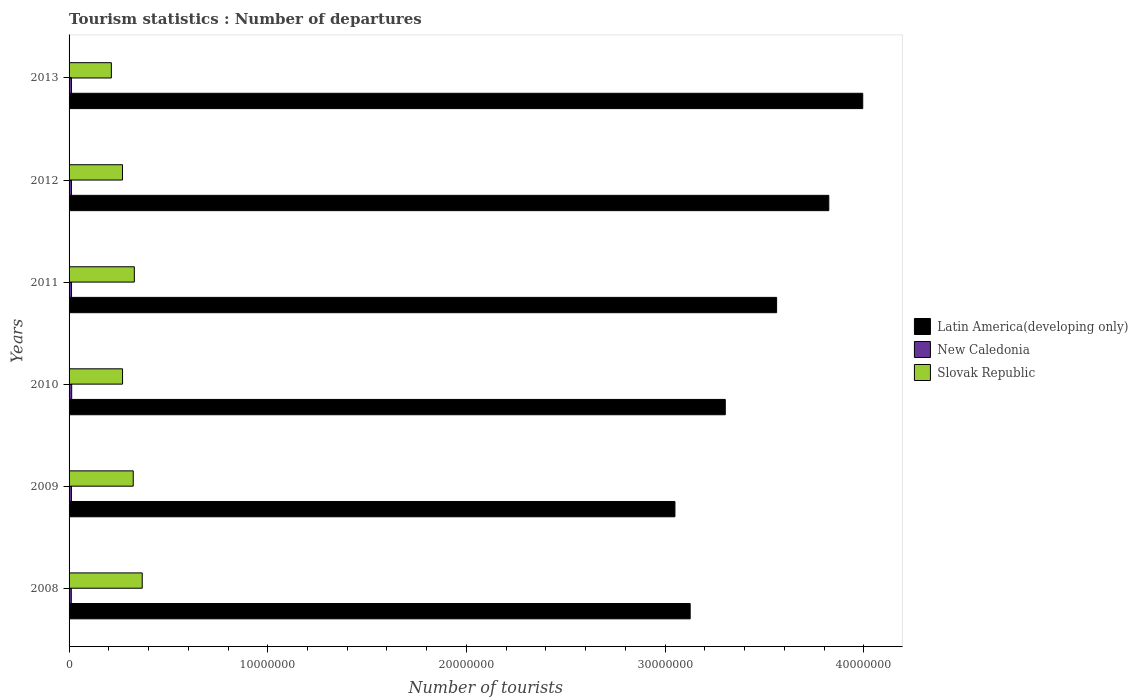How many different coloured bars are there?
Provide a succinct answer. 3. How many groups of bars are there?
Your response must be concise. 6. Are the number of bars per tick equal to the number of legend labels?
Your response must be concise. Yes. Are the number of bars on each tick of the Y-axis equal?
Your answer should be compact. Yes. How many bars are there on the 6th tick from the top?
Give a very brief answer. 3. What is the label of the 1st group of bars from the top?
Your answer should be very brief. 2013. What is the number of tourist departures in New Caledonia in 2012?
Provide a succinct answer. 1.21e+05. Across all years, what is the maximum number of tourist departures in Slovak Republic?
Your response must be concise. 3.68e+06. Across all years, what is the minimum number of tourist departures in New Caledonia?
Keep it short and to the point. 1.12e+05. What is the total number of tourist departures in Slovak Republic in the graph?
Offer a terse response. 1.77e+07. What is the difference between the number of tourist departures in Slovak Republic in 2009 and that in 2012?
Ensure brevity in your answer.  5.41e+05. What is the difference between the number of tourist departures in Slovak Republic in 2010 and the number of tourist departures in New Caledonia in 2009?
Keep it short and to the point. 2.57e+06. What is the average number of tourist departures in Slovak Republic per year?
Provide a succinct answer. 2.95e+06. In the year 2008, what is the difference between the number of tourist departures in Latin America(developing only) and number of tourist departures in Slovak Republic?
Provide a succinct answer. 2.76e+07. What is the ratio of the number of tourist departures in Latin America(developing only) in 2009 to that in 2012?
Provide a succinct answer. 0.8. What is the difference between the highest and the second highest number of tourist departures in New Caledonia?
Make the answer very short. 8000. What is the difference between the highest and the lowest number of tourist departures in Latin America(developing only)?
Ensure brevity in your answer.  9.45e+06. What does the 2nd bar from the top in 2008 represents?
Your answer should be very brief. New Caledonia. What does the 2nd bar from the bottom in 2010 represents?
Offer a very short reply. New Caledonia. How many bars are there?
Your answer should be compact. 18. Are all the bars in the graph horizontal?
Offer a terse response. Yes. What is the difference between two consecutive major ticks on the X-axis?
Give a very brief answer. 1.00e+07. Are the values on the major ticks of X-axis written in scientific E-notation?
Give a very brief answer. No. Does the graph contain any zero values?
Make the answer very short. No. Does the graph contain grids?
Your response must be concise. No. How many legend labels are there?
Keep it short and to the point. 3. What is the title of the graph?
Your response must be concise. Tourism statistics : Number of departures. What is the label or title of the X-axis?
Ensure brevity in your answer.  Number of tourists. What is the Number of tourists in Latin America(developing only) in 2008?
Make the answer very short. 3.13e+07. What is the Number of tourists of New Caledonia in 2008?
Give a very brief answer. 1.12e+05. What is the Number of tourists in Slovak Republic in 2008?
Your answer should be very brief. 3.68e+06. What is the Number of tourists in Latin America(developing only) in 2009?
Keep it short and to the point. 3.05e+07. What is the Number of tourists in New Caledonia in 2009?
Offer a very short reply. 1.19e+05. What is the Number of tourists in Slovak Republic in 2009?
Provide a succinct answer. 3.23e+06. What is the Number of tourists in Latin America(developing only) in 2010?
Ensure brevity in your answer.  3.30e+07. What is the Number of tourists of New Caledonia in 2010?
Your answer should be compact. 1.32e+05. What is the Number of tourists of Slovak Republic in 2010?
Provide a succinct answer. 2.69e+06. What is the Number of tourists of Latin America(developing only) in 2011?
Your answer should be very brief. 3.56e+07. What is the Number of tourists of New Caledonia in 2011?
Offer a very short reply. 1.24e+05. What is the Number of tourists of Slovak Republic in 2011?
Make the answer very short. 3.28e+06. What is the Number of tourists of Latin America(developing only) in 2012?
Give a very brief answer. 3.82e+07. What is the Number of tourists in New Caledonia in 2012?
Give a very brief answer. 1.21e+05. What is the Number of tourists in Slovak Republic in 2012?
Give a very brief answer. 2.69e+06. What is the Number of tourists of Latin America(developing only) in 2013?
Ensure brevity in your answer.  3.99e+07. What is the Number of tourists of New Caledonia in 2013?
Provide a succinct answer. 1.21e+05. What is the Number of tourists of Slovak Republic in 2013?
Your response must be concise. 2.13e+06. Across all years, what is the maximum Number of tourists of Latin America(developing only)?
Provide a succinct answer. 3.99e+07. Across all years, what is the maximum Number of tourists of New Caledonia?
Offer a very short reply. 1.32e+05. Across all years, what is the maximum Number of tourists in Slovak Republic?
Provide a short and direct response. 3.68e+06. Across all years, what is the minimum Number of tourists in Latin America(developing only)?
Offer a terse response. 3.05e+07. Across all years, what is the minimum Number of tourists in New Caledonia?
Ensure brevity in your answer.  1.12e+05. Across all years, what is the minimum Number of tourists in Slovak Republic?
Offer a very short reply. 2.13e+06. What is the total Number of tourists of Latin America(developing only) in the graph?
Your answer should be very brief. 2.09e+08. What is the total Number of tourists in New Caledonia in the graph?
Provide a short and direct response. 7.29e+05. What is the total Number of tourists in Slovak Republic in the graph?
Ensure brevity in your answer.  1.77e+07. What is the difference between the Number of tourists of Latin America(developing only) in 2008 and that in 2009?
Offer a terse response. 7.67e+05. What is the difference between the Number of tourists of New Caledonia in 2008 and that in 2009?
Ensure brevity in your answer.  -7000. What is the difference between the Number of tourists of Slovak Republic in 2008 and that in 2009?
Offer a terse response. 4.53e+05. What is the difference between the Number of tourists in Latin America(developing only) in 2008 and that in 2010?
Ensure brevity in your answer.  -1.77e+06. What is the difference between the Number of tourists of Slovak Republic in 2008 and that in 2010?
Offer a very short reply. 9.91e+05. What is the difference between the Number of tourists of Latin America(developing only) in 2008 and that in 2011?
Ensure brevity in your answer.  -4.35e+06. What is the difference between the Number of tourists of New Caledonia in 2008 and that in 2011?
Provide a short and direct response. -1.20e+04. What is the difference between the Number of tourists of Slovak Republic in 2008 and that in 2011?
Your answer should be very brief. 3.98e+05. What is the difference between the Number of tourists in Latin America(developing only) in 2008 and that in 2012?
Your answer should be very brief. -6.98e+06. What is the difference between the Number of tourists of New Caledonia in 2008 and that in 2012?
Provide a short and direct response. -9000. What is the difference between the Number of tourists in Slovak Republic in 2008 and that in 2012?
Your response must be concise. 9.94e+05. What is the difference between the Number of tourists in Latin America(developing only) in 2008 and that in 2013?
Give a very brief answer. -8.69e+06. What is the difference between the Number of tourists of New Caledonia in 2008 and that in 2013?
Ensure brevity in your answer.  -9000. What is the difference between the Number of tourists of Slovak Republic in 2008 and that in 2013?
Keep it short and to the point. 1.55e+06. What is the difference between the Number of tourists in Latin America(developing only) in 2009 and that in 2010?
Offer a very short reply. -2.53e+06. What is the difference between the Number of tourists of New Caledonia in 2009 and that in 2010?
Your answer should be very brief. -1.30e+04. What is the difference between the Number of tourists of Slovak Republic in 2009 and that in 2010?
Offer a terse response. 5.38e+05. What is the difference between the Number of tourists of Latin America(developing only) in 2009 and that in 2011?
Your answer should be compact. -5.12e+06. What is the difference between the Number of tourists in New Caledonia in 2009 and that in 2011?
Your response must be concise. -5000. What is the difference between the Number of tourists in Slovak Republic in 2009 and that in 2011?
Your answer should be compact. -5.50e+04. What is the difference between the Number of tourists of Latin America(developing only) in 2009 and that in 2012?
Your answer should be very brief. -7.74e+06. What is the difference between the Number of tourists of New Caledonia in 2009 and that in 2012?
Offer a terse response. -2000. What is the difference between the Number of tourists in Slovak Republic in 2009 and that in 2012?
Your answer should be very brief. 5.41e+05. What is the difference between the Number of tourists of Latin America(developing only) in 2009 and that in 2013?
Make the answer very short. -9.45e+06. What is the difference between the Number of tourists in New Caledonia in 2009 and that in 2013?
Your answer should be compact. -2000. What is the difference between the Number of tourists in Slovak Republic in 2009 and that in 2013?
Provide a succinct answer. 1.10e+06. What is the difference between the Number of tourists in Latin America(developing only) in 2010 and that in 2011?
Give a very brief answer. -2.58e+06. What is the difference between the Number of tourists in New Caledonia in 2010 and that in 2011?
Keep it short and to the point. 8000. What is the difference between the Number of tourists of Slovak Republic in 2010 and that in 2011?
Ensure brevity in your answer.  -5.93e+05. What is the difference between the Number of tourists in Latin America(developing only) in 2010 and that in 2012?
Your response must be concise. -5.21e+06. What is the difference between the Number of tourists in New Caledonia in 2010 and that in 2012?
Provide a succinct answer. 1.10e+04. What is the difference between the Number of tourists in Slovak Republic in 2010 and that in 2012?
Provide a succinct answer. 3000. What is the difference between the Number of tourists in Latin America(developing only) in 2010 and that in 2013?
Ensure brevity in your answer.  -6.92e+06. What is the difference between the Number of tourists in New Caledonia in 2010 and that in 2013?
Offer a very short reply. 1.10e+04. What is the difference between the Number of tourists of Slovak Republic in 2010 and that in 2013?
Offer a terse response. 5.63e+05. What is the difference between the Number of tourists of Latin America(developing only) in 2011 and that in 2012?
Provide a short and direct response. -2.63e+06. What is the difference between the Number of tourists of New Caledonia in 2011 and that in 2012?
Offer a very short reply. 3000. What is the difference between the Number of tourists of Slovak Republic in 2011 and that in 2012?
Your answer should be compact. 5.96e+05. What is the difference between the Number of tourists in Latin America(developing only) in 2011 and that in 2013?
Provide a short and direct response. -4.33e+06. What is the difference between the Number of tourists of New Caledonia in 2011 and that in 2013?
Offer a very short reply. 3000. What is the difference between the Number of tourists of Slovak Republic in 2011 and that in 2013?
Keep it short and to the point. 1.16e+06. What is the difference between the Number of tourists of Latin America(developing only) in 2012 and that in 2013?
Give a very brief answer. -1.71e+06. What is the difference between the Number of tourists of New Caledonia in 2012 and that in 2013?
Make the answer very short. 0. What is the difference between the Number of tourists of Slovak Republic in 2012 and that in 2013?
Your answer should be very brief. 5.60e+05. What is the difference between the Number of tourists in Latin America(developing only) in 2008 and the Number of tourists in New Caledonia in 2009?
Keep it short and to the point. 3.11e+07. What is the difference between the Number of tourists of Latin America(developing only) in 2008 and the Number of tourists of Slovak Republic in 2009?
Your answer should be compact. 2.80e+07. What is the difference between the Number of tourists in New Caledonia in 2008 and the Number of tourists in Slovak Republic in 2009?
Your response must be concise. -3.12e+06. What is the difference between the Number of tourists in Latin America(developing only) in 2008 and the Number of tourists in New Caledonia in 2010?
Your answer should be compact. 3.11e+07. What is the difference between the Number of tourists in Latin America(developing only) in 2008 and the Number of tourists in Slovak Republic in 2010?
Give a very brief answer. 2.86e+07. What is the difference between the Number of tourists of New Caledonia in 2008 and the Number of tourists of Slovak Republic in 2010?
Offer a terse response. -2.58e+06. What is the difference between the Number of tourists of Latin America(developing only) in 2008 and the Number of tourists of New Caledonia in 2011?
Make the answer very short. 3.11e+07. What is the difference between the Number of tourists of Latin America(developing only) in 2008 and the Number of tourists of Slovak Republic in 2011?
Offer a very short reply. 2.80e+07. What is the difference between the Number of tourists in New Caledonia in 2008 and the Number of tourists in Slovak Republic in 2011?
Make the answer very short. -3.17e+06. What is the difference between the Number of tourists in Latin America(developing only) in 2008 and the Number of tourists in New Caledonia in 2012?
Your answer should be compact. 3.11e+07. What is the difference between the Number of tourists in Latin America(developing only) in 2008 and the Number of tourists in Slovak Republic in 2012?
Keep it short and to the point. 2.86e+07. What is the difference between the Number of tourists of New Caledonia in 2008 and the Number of tourists of Slovak Republic in 2012?
Make the answer very short. -2.58e+06. What is the difference between the Number of tourists of Latin America(developing only) in 2008 and the Number of tourists of New Caledonia in 2013?
Ensure brevity in your answer.  3.11e+07. What is the difference between the Number of tourists in Latin America(developing only) in 2008 and the Number of tourists in Slovak Republic in 2013?
Provide a succinct answer. 2.91e+07. What is the difference between the Number of tourists of New Caledonia in 2008 and the Number of tourists of Slovak Republic in 2013?
Provide a short and direct response. -2.02e+06. What is the difference between the Number of tourists in Latin America(developing only) in 2009 and the Number of tourists in New Caledonia in 2010?
Offer a very short reply. 3.04e+07. What is the difference between the Number of tourists in Latin America(developing only) in 2009 and the Number of tourists in Slovak Republic in 2010?
Offer a very short reply. 2.78e+07. What is the difference between the Number of tourists of New Caledonia in 2009 and the Number of tourists of Slovak Republic in 2010?
Offer a terse response. -2.57e+06. What is the difference between the Number of tourists of Latin America(developing only) in 2009 and the Number of tourists of New Caledonia in 2011?
Offer a terse response. 3.04e+07. What is the difference between the Number of tourists in Latin America(developing only) in 2009 and the Number of tourists in Slovak Republic in 2011?
Your answer should be compact. 2.72e+07. What is the difference between the Number of tourists in New Caledonia in 2009 and the Number of tourists in Slovak Republic in 2011?
Provide a succinct answer. -3.17e+06. What is the difference between the Number of tourists of Latin America(developing only) in 2009 and the Number of tourists of New Caledonia in 2012?
Provide a short and direct response. 3.04e+07. What is the difference between the Number of tourists of Latin America(developing only) in 2009 and the Number of tourists of Slovak Republic in 2012?
Your response must be concise. 2.78e+07. What is the difference between the Number of tourists in New Caledonia in 2009 and the Number of tourists in Slovak Republic in 2012?
Your answer should be very brief. -2.57e+06. What is the difference between the Number of tourists in Latin America(developing only) in 2009 and the Number of tourists in New Caledonia in 2013?
Offer a terse response. 3.04e+07. What is the difference between the Number of tourists of Latin America(developing only) in 2009 and the Number of tourists of Slovak Republic in 2013?
Offer a very short reply. 2.84e+07. What is the difference between the Number of tourists of New Caledonia in 2009 and the Number of tourists of Slovak Republic in 2013?
Ensure brevity in your answer.  -2.01e+06. What is the difference between the Number of tourists of Latin America(developing only) in 2010 and the Number of tourists of New Caledonia in 2011?
Ensure brevity in your answer.  3.29e+07. What is the difference between the Number of tourists in Latin America(developing only) in 2010 and the Number of tourists in Slovak Republic in 2011?
Give a very brief answer. 2.97e+07. What is the difference between the Number of tourists in New Caledonia in 2010 and the Number of tourists in Slovak Republic in 2011?
Your response must be concise. -3.15e+06. What is the difference between the Number of tourists in Latin America(developing only) in 2010 and the Number of tourists in New Caledonia in 2012?
Your answer should be very brief. 3.29e+07. What is the difference between the Number of tourists of Latin America(developing only) in 2010 and the Number of tourists of Slovak Republic in 2012?
Provide a short and direct response. 3.03e+07. What is the difference between the Number of tourists of New Caledonia in 2010 and the Number of tourists of Slovak Republic in 2012?
Provide a short and direct response. -2.56e+06. What is the difference between the Number of tourists of Latin America(developing only) in 2010 and the Number of tourists of New Caledonia in 2013?
Your response must be concise. 3.29e+07. What is the difference between the Number of tourists in Latin America(developing only) in 2010 and the Number of tourists in Slovak Republic in 2013?
Provide a short and direct response. 3.09e+07. What is the difference between the Number of tourists of New Caledonia in 2010 and the Number of tourists of Slovak Republic in 2013?
Offer a very short reply. -2.00e+06. What is the difference between the Number of tourists of Latin America(developing only) in 2011 and the Number of tourists of New Caledonia in 2012?
Give a very brief answer. 3.55e+07. What is the difference between the Number of tourists of Latin America(developing only) in 2011 and the Number of tourists of Slovak Republic in 2012?
Offer a very short reply. 3.29e+07. What is the difference between the Number of tourists of New Caledonia in 2011 and the Number of tourists of Slovak Republic in 2012?
Offer a terse response. -2.56e+06. What is the difference between the Number of tourists in Latin America(developing only) in 2011 and the Number of tourists in New Caledonia in 2013?
Your response must be concise. 3.55e+07. What is the difference between the Number of tourists in Latin America(developing only) in 2011 and the Number of tourists in Slovak Republic in 2013?
Keep it short and to the point. 3.35e+07. What is the difference between the Number of tourists of New Caledonia in 2011 and the Number of tourists of Slovak Republic in 2013?
Offer a terse response. -2.00e+06. What is the difference between the Number of tourists of Latin America(developing only) in 2012 and the Number of tourists of New Caledonia in 2013?
Your response must be concise. 3.81e+07. What is the difference between the Number of tourists in Latin America(developing only) in 2012 and the Number of tourists in Slovak Republic in 2013?
Your answer should be very brief. 3.61e+07. What is the difference between the Number of tourists in New Caledonia in 2012 and the Number of tourists in Slovak Republic in 2013?
Offer a very short reply. -2.01e+06. What is the average Number of tourists of Latin America(developing only) per year?
Offer a terse response. 3.48e+07. What is the average Number of tourists in New Caledonia per year?
Your answer should be very brief. 1.22e+05. What is the average Number of tourists in Slovak Republic per year?
Your answer should be compact. 2.95e+06. In the year 2008, what is the difference between the Number of tourists of Latin America(developing only) and Number of tourists of New Caledonia?
Offer a very short reply. 3.12e+07. In the year 2008, what is the difference between the Number of tourists of Latin America(developing only) and Number of tourists of Slovak Republic?
Keep it short and to the point. 2.76e+07. In the year 2008, what is the difference between the Number of tourists of New Caledonia and Number of tourists of Slovak Republic?
Provide a short and direct response. -3.57e+06. In the year 2009, what is the difference between the Number of tourists of Latin America(developing only) and Number of tourists of New Caledonia?
Your answer should be very brief. 3.04e+07. In the year 2009, what is the difference between the Number of tourists of Latin America(developing only) and Number of tourists of Slovak Republic?
Give a very brief answer. 2.73e+07. In the year 2009, what is the difference between the Number of tourists in New Caledonia and Number of tourists in Slovak Republic?
Offer a terse response. -3.11e+06. In the year 2010, what is the difference between the Number of tourists in Latin America(developing only) and Number of tourists in New Caledonia?
Make the answer very short. 3.29e+07. In the year 2010, what is the difference between the Number of tourists of Latin America(developing only) and Number of tourists of Slovak Republic?
Your answer should be very brief. 3.03e+07. In the year 2010, what is the difference between the Number of tourists of New Caledonia and Number of tourists of Slovak Republic?
Your answer should be very brief. -2.56e+06. In the year 2011, what is the difference between the Number of tourists of Latin America(developing only) and Number of tourists of New Caledonia?
Ensure brevity in your answer.  3.55e+07. In the year 2011, what is the difference between the Number of tourists in Latin America(developing only) and Number of tourists in Slovak Republic?
Make the answer very short. 3.23e+07. In the year 2011, what is the difference between the Number of tourists of New Caledonia and Number of tourists of Slovak Republic?
Your answer should be compact. -3.16e+06. In the year 2012, what is the difference between the Number of tourists in Latin America(developing only) and Number of tourists in New Caledonia?
Ensure brevity in your answer.  3.81e+07. In the year 2012, what is the difference between the Number of tourists of Latin America(developing only) and Number of tourists of Slovak Republic?
Your answer should be very brief. 3.56e+07. In the year 2012, what is the difference between the Number of tourists of New Caledonia and Number of tourists of Slovak Republic?
Offer a very short reply. -2.57e+06. In the year 2013, what is the difference between the Number of tourists in Latin America(developing only) and Number of tourists in New Caledonia?
Provide a short and direct response. 3.98e+07. In the year 2013, what is the difference between the Number of tourists in Latin America(developing only) and Number of tourists in Slovak Republic?
Your answer should be very brief. 3.78e+07. In the year 2013, what is the difference between the Number of tourists of New Caledonia and Number of tourists of Slovak Republic?
Your answer should be compact. -2.01e+06. What is the ratio of the Number of tourists in Latin America(developing only) in 2008 to that in 2009?
Offer a very short reply. 1.03. What is the ratio of the Number of tourists in Slovak Republic in 2008 to that in 2009?
Your answer should be very brief. 1.14. What is the ratio of the Number of tourists of Latin America(developing only) in 2008 to that in 2010?
Give a very brief answer. 0.95. What is the ratio of the Number of tourists in New Caledonia in 2008 to that in 2010?
Make the answer very short. 0.85. What is the ratio of the Number of tourists of Slovak Republic in 2008 to that in 2010?
Keep it short and to the point. 1.37. What is the ratio of the Number of tourists of Latin America(developing only) in 2008 to that in 2011?
Make the answer very short. 0.88. What is the ratio of the Number of tourists in New Caledonia in 2008 to that in 2011?
Give a very brief answer. 0.9. What is the ratio of the Number of tourists in Slovak Republic in 2008 to that in 2011?
Keep it short and to the point. 1.12. What is the ratio of the Number of tourists of Latin America(developing only) in 2008 to that in 2012?
Your answer should be compact. 0.82. What is the ratio of the Number of tourists in New Caledonia in 2008 to that in 2012?
Your answer should be very brief. 0.93. What is the ratio of the Number of tourists in Slovak Republic in 2008 to that in 2012?
Provide a short and direct response. 1.37. What is the ratio of the Number of tourists of Latin America(developing only) in 2008 to that in 2013?
Your response must be concise. 0.78. What is the ratio of the Number of tourists in New Caledonia in 2008 to that in 2013?
Keep it short and to the point. 0.93. What is the ratio of the Number of tourists in Slovak Republic in 2008 to that in 2013?
Provide a short and direct response. 1.73. What is the ratio of the Number of tourists of Latin America(developing only) in 2009 to that in 2010?
Offer a terse response. 0.92. What is the ratio of the Number of tourists in New Caledonia in 2009 to that in 2010?
Your answer should be compact. 0.9. What is the ratio of the Number of tourists of Slovak Republic in 2009 to that in 2010?
Ensure brevity in your answer.  1.2. What is the ratio of the Number of tourists of Latin America(developing only) in 2009 to that in 2011?
Give a very brief answer. 0.86. What is the ratio of the Number of tourists of New Caledonia in 2009 to that in 2011?
Keep it short and to the point. 0.96. What is the ratio of the Number of tourists in Slovak Republic in 2009 to that in 2011?
Offer a very short reply. 0.98. What is the ratio of the Number of tourists in Latin America(developing only) in 2009 to that in 2012?
Your response must be concise. 0.8. What is the ratio of the Number of tourists of New Caledonia in 2009 to that in 2012?
Offer a terse response. 0.98. What is the ratio of the Number of tourists of Slovak Republic in 2009 to that in 2012?
Offer a terse response. 1.2. What is the ratio of the Number of tourists in Latin America(developing only) in 2009 to that in 2013?
Your answer should be very brief. 0.76. What is the ratio of the Number of tourists of New Caledonia in 2009 to that in 2013?
Ensure brevity in your answer.  0.98. What is the ratio of the Number of tourists of Slovak Republic in 2009 to that in 2013?
Offer a terse response. 1.52. What is the ratio of the Number of tourists of Latin America(developing only) in 2010 to that in 2011?
Offer a very short reply. 0.93. What is the ratio of the Number of tourists in New Caledonia in 2010 to that in 2011?
Provide a short and direct response. 1.06. What is the ratio of the Number of tourists in Slovak Republic in 2010 to that in 2011?
Your response must be concise. 0.82. What is the ratio of the Number of tourists in Latin America(developing only) in 2010 to that in 2012?
Offer a very short reply. 0.86. What is the ratio of the Number of tourists of Slovak Republic in 2010 to that in 2012?
Ensure brevity in your answer.  1. What is the ratio of the Number of tourists of Latin America(developing only) in 2010 to that in 2013?
Your answer should be very brief. 0.83. What is the ratio of the Number of tourists of New Caledonia in 2010 to that in 2013?
Your answer should be compact. 1.09. What is the ratio of the Number of tourists of Slovak Republic in 2010 to that in 2013?
Provide a succinct answer. 1.26. What is the ratio of the Number of tourists in Latin America(developing only) in 2011 to that in 2012?
Ensure brevity in your answer.  0.93. What is the ratio of the Number of tourists in New Caledonia in 2011 to that in 2012?
Make the answer very short. 1.02. What is the ratio of the Number of tourists in Slovak Republic in 2011 to that in 2012?
Keep it short and to the point. 1.22. What is the ratio of the Number of tourists of Latin America(developing only) in 2011 to that in 2013?
Ensure brevity in your answer.  0.89. What is the ratio of the Number of tourists of New Caledonia in 2011 to that in 2013?
Keep it short and to the point. 1.02. What is the ratio of the Number of tourists of Slovak Republic in 2011 to that in 2013?
Ensure brevity in your answer.  1.54. What is the ratio of the Number of tourists of Latin America(developing only) in 2012 to that in 2013?
Provide a succinct answer. 0.96. What is the ratio of the Number of tourists of New Caledonia in 2012 to that in 2013?
Keep it short and to the point. 1. What is the ratio of the Number of tourists of Slovak Republic in 2012 to that in 2013?
Your answer should be very brief. 1.26. What is the difference between the highest and the second highest Number of tourists of Latin America(developing only)?
Give a very brief answer. 1.71e+06. What is the difference between the highest and the second highest Number of tourists in New Caledonia?
Your answer should be very brief. 8000. What is the difference between the highest and the second highest Number of tourists of Slovak Republic?
Your answer should be compact. 3.98e+05. What is the difference between the highest and the lowest Number of tourists in Latin America(developing only)?
Your answer should be compact. 9.45e+06. What is the difference between the highest and the lowest Number of tourists in New Caledonia?
Give a very brief answer. 2.00e+04. What is the difference between the highest and the lowest Number of tourists in Slovak Republic?
Ensure brevity in your answer.  1.55e+06. 